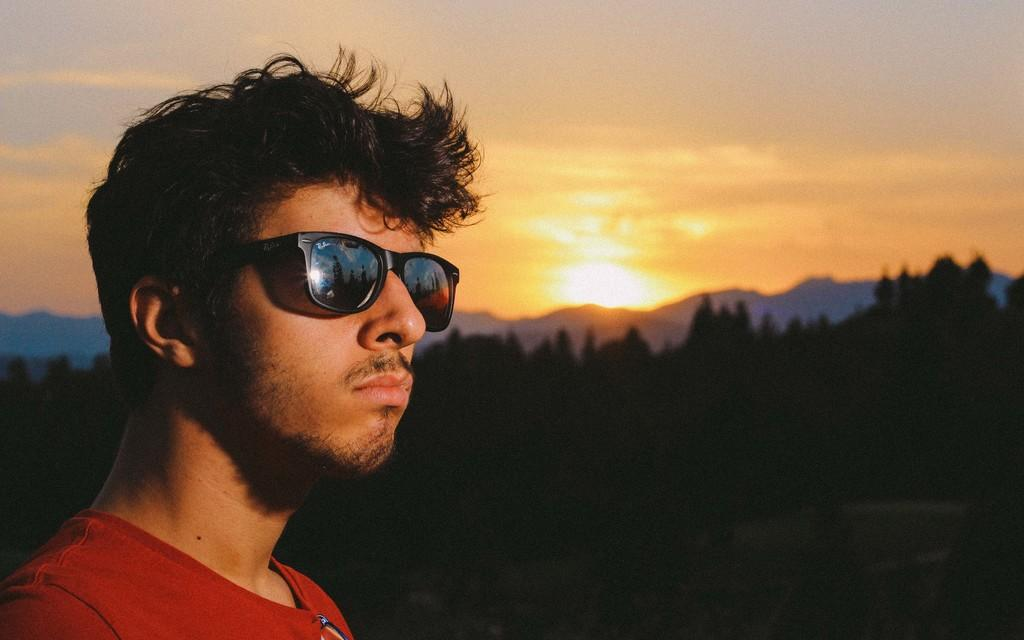Who is present in the image? There is a man in the image. What accessory is the man wearing? The man is wearing glasses. What type of vegetation can be seen in the image? There is a group of trees visible in the image. What geographical features are in the background of the image? There are hills in the background of the image. What celestial body is visible in the image? The sun is visible in the image. How would you describe the weather in the image? The sky appears cloudy in the image. Is the man experiencing pain in the image? There is no indication in the image that the man is experiencing pain. Is it raining in the image? There is no indication of rain in the image; the sky appears cloudy, but no rain is visible. 